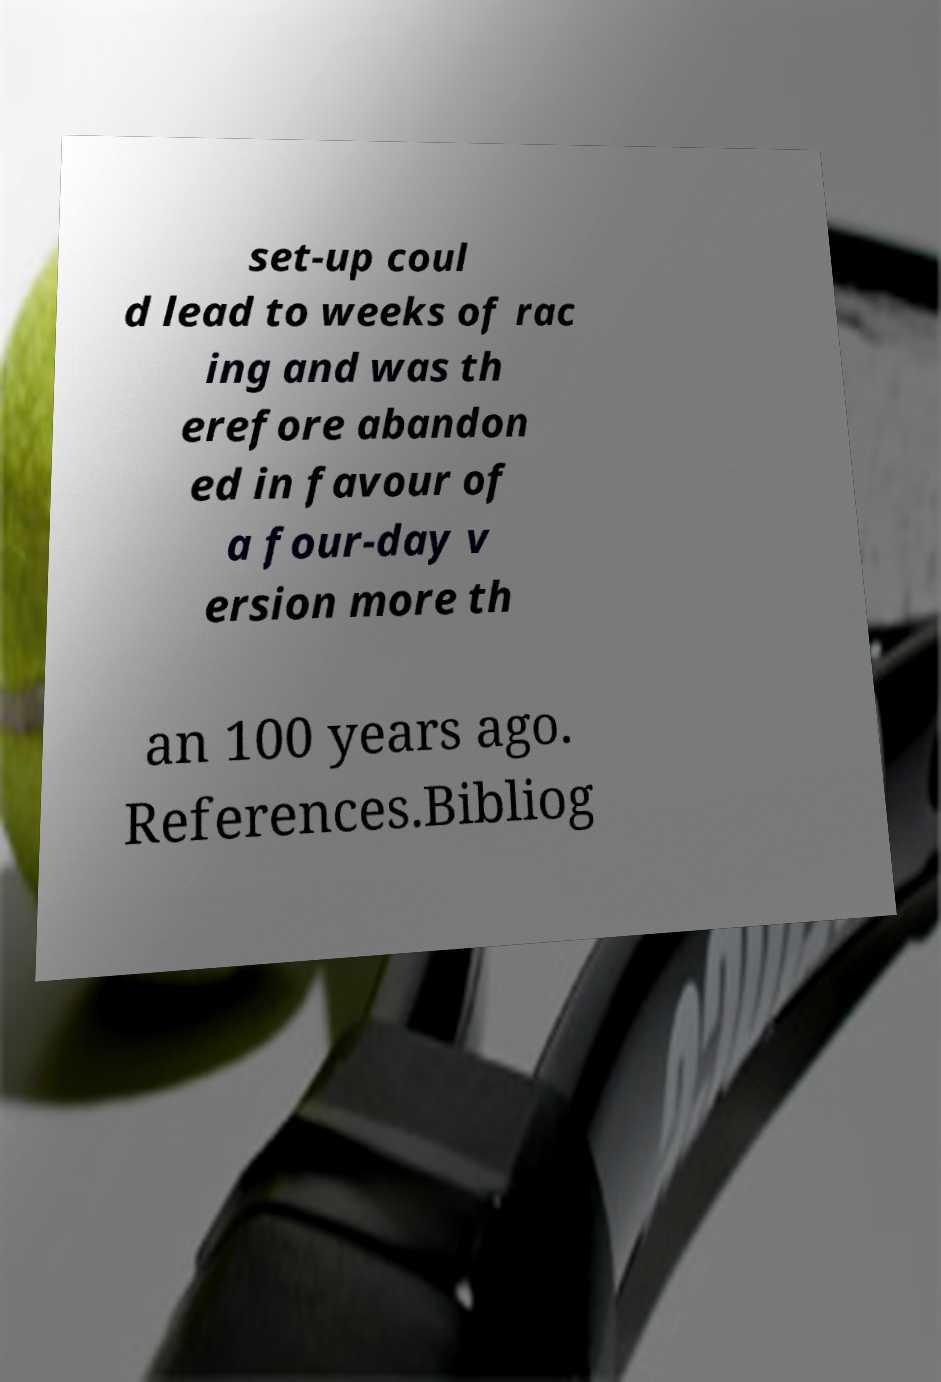For documentation purposes, I need the text within this image transcribed. Could you provide that? set-up coul d lead to weeks of rac ing and was th erefore abandon ed in favour of a four-day v ersion more th an 100 years ago. References.Bibliog 